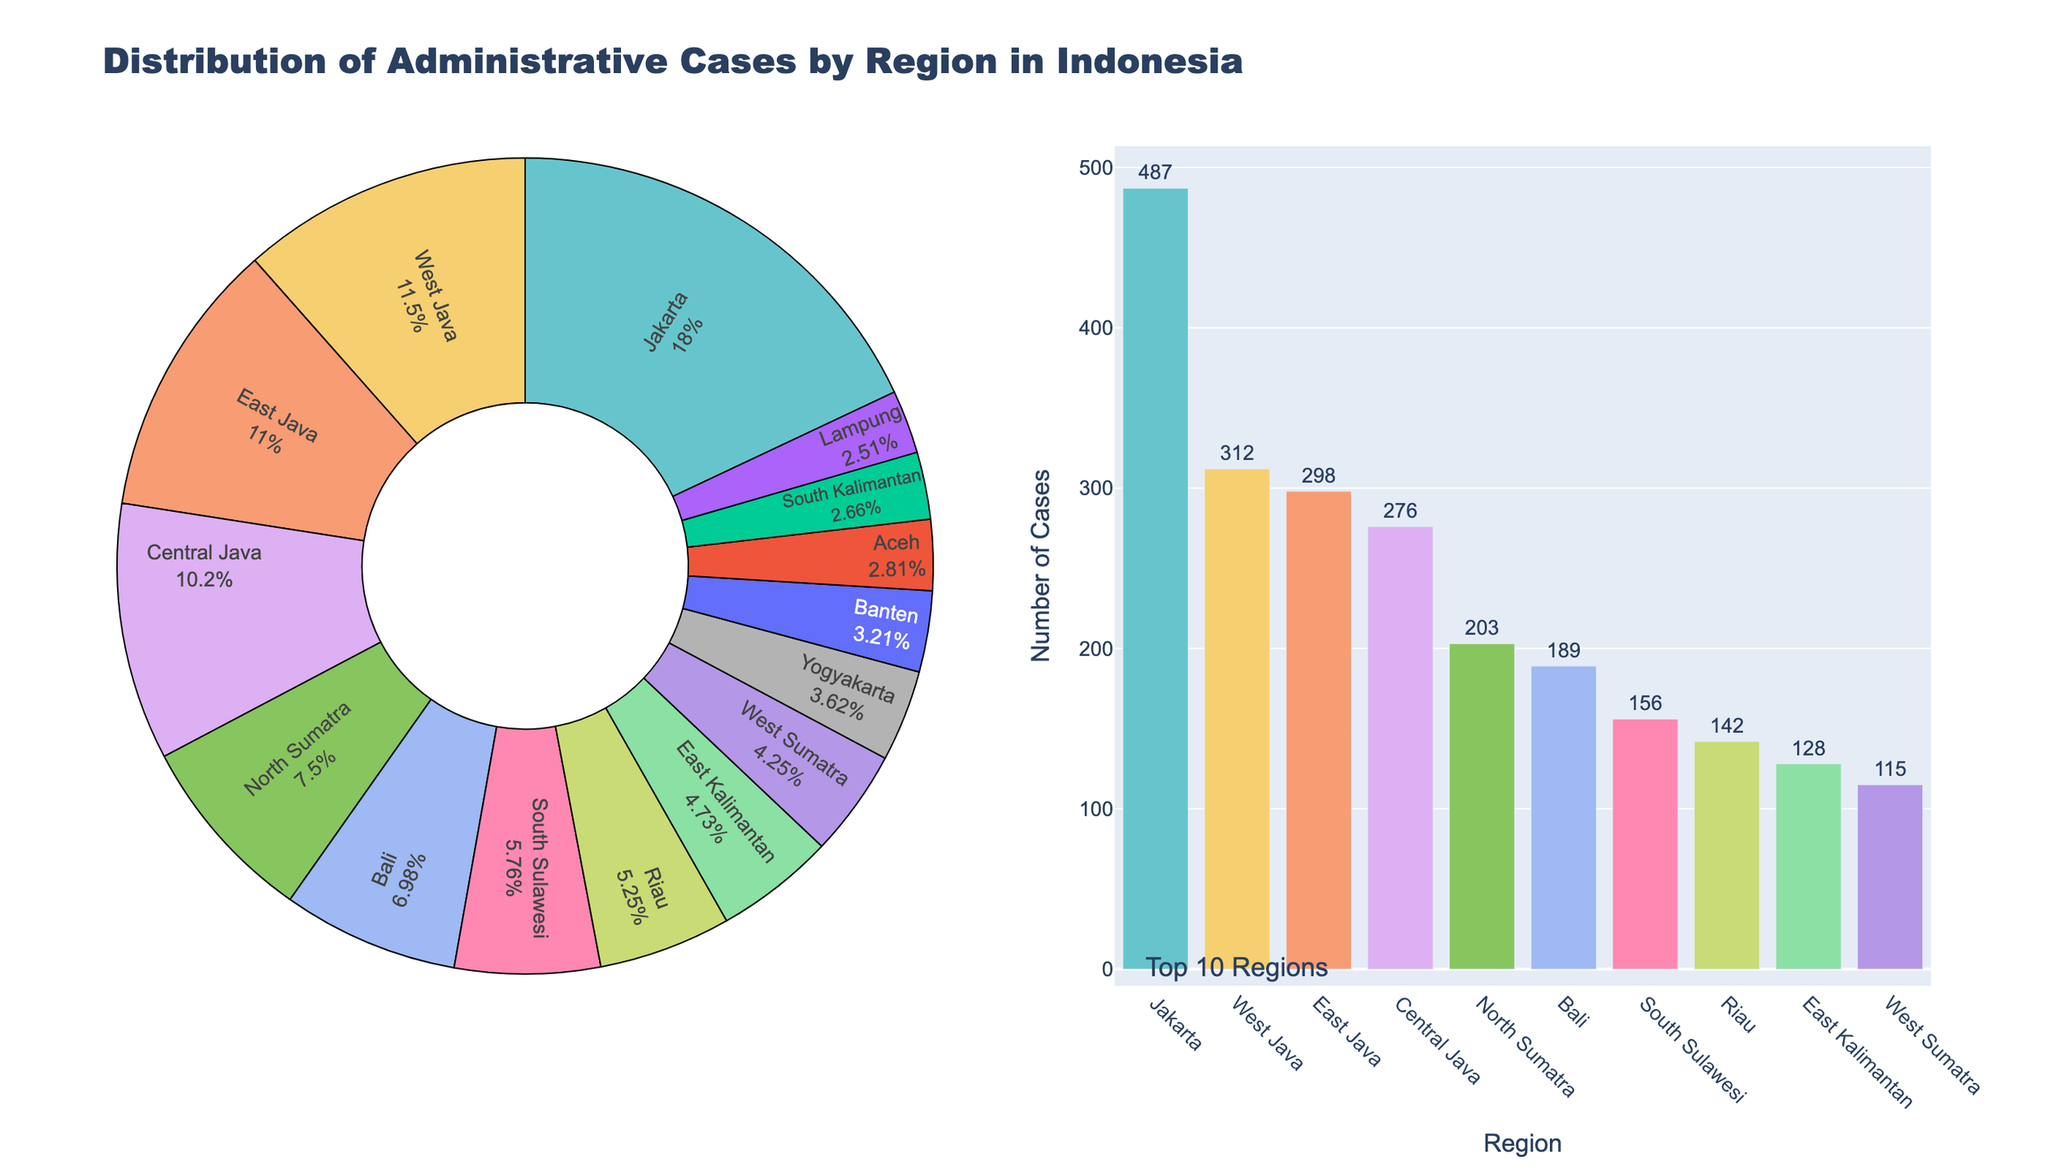What percentage of administrative cases are from Jakarta? Locate the segment labeled "Jakarta" on the pie chart. The text inside indicates the percentage share of Jakarta's cases based on the total number of cases.
Answer: 19.2% Which region has the second-highest number of administrative cases? Examine the bar chart and identify the region corresponding to the second highest bar. The labels and corresponding values will help you identify the region.
Answer: West Java How many more cases are in Bali compared to Banten? Identify the number of cases for Bali and Banten from either the pie chart or the bar chart. Subtract the number of cases in Banten from the number of cases in Bali: 189 - 87.
Answer: 102 Are the total cases in Central Java and East Java more or less than those in Jakarta? Sum the cases in Central Java and East Java from the data (276 + 298 = 574) and compare this with Jakarta's cases (487). 574 - 487, so it's more.
Answer: More Which regions comprise the top 5 in terms of case numbers and what is the combined percentage they represent? Find the top 5 regions from the bar chart: Jakarta, West Java, East Java, Central Java, and North Sumatra. Sum their percentages from the pie chart.
Answer: Jakarta (19.2) + West Java (12.3) + East Java (11.8) + Central Java (11.0) + North Sumatra (8.0) = 62.3% Does Riau have a higher percentage of cases than East Kalimantan? Identify the segments for Riau and East Kalimantan on the pie chart. Compare their percentage labels.
Answer: Yes What's the difference in the number of cases between the region with the highest and the region with the lowest case counts? Subtract the number of cases in Aceh (76) from the number of cases in Jakarta (487): 487 - 76.
Answer: 411 Which two regions have a similar number of administrative cases, and what are their counts? Look at the bar chart for bars of similar height and verify with the numerical values: East Java (298) and Central Java (276).
Answer: East Java: 298, Central Java: 276 What region accounts for approximately 7.6% of the administrative cases? Locate the segment with 7.6% on the pie chart and check the label.
Answer: South Sulawesi If you were to combine the cases from North Sumatra and Bali, what fraction of the total cases would this represent? Sum the cases in North Sumatra and Bali (203 + 189 = 392). Divide this by the total number of cases (total derived by summing all entries): 392/2803 ≈ 0.14.
Answer: Approximately 14% 